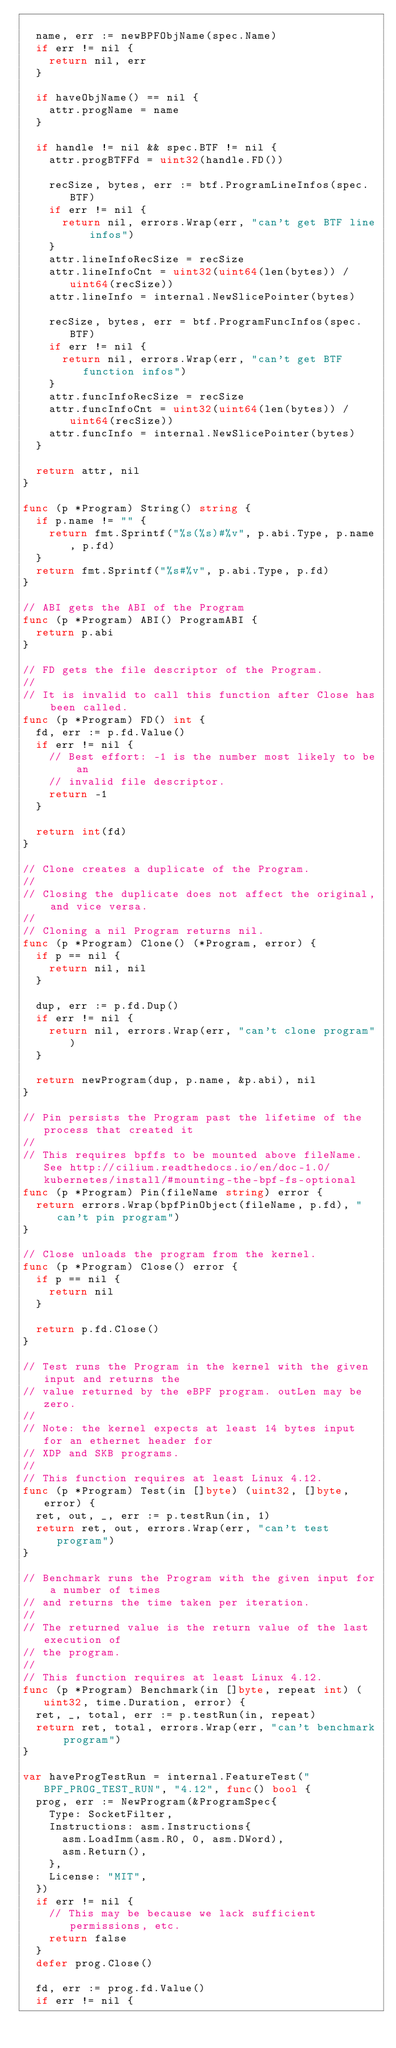<code> <loc_0><loc_0><loc_500><loc_500><_Go_>
	name, err := newBPFObjName(spec.Name)
	if err != nil {
		return nil, err
	}

	if haveObjName() == nil {
		attr.progName = name
	}

	if handle != nil && spec.BTF != nil {
		attr.progBTFFd = uint32(handle.FD())

		recSize, bytes, err := btf.ProgramLineInfos(spec.BTF)
		if err != nil {
			return nil, errors.Wrap(err, "can't get BTF line infos")
		}
		attr.lineInfoRecSize = recSize
		attr.lineInfoCnt = uint32(uint64(len(bytes)) / uint64(recSize))
		attr.lineInfo = internal.NewSlicePointer(bytes)

		recSize, bytes, err = btf.ProgramFuncInfos(spec.BTF)
		if err != nil {
			return nil, errors.Wrap(err, "can't get BTF function infos")
		}
		attr.funcInfoRecSize = recSize
		attr.funcInfoCnt = uint32(uint64(len(bytes)) / uint64(recSize))
		attr.funcInfo = internal.NewSlicePointer(bytes)
	}

	return attr, nil
}

func (p *Program) String() string {
	if p.name != "" {
		return fmt.Sprintf("%s(%s)#%v", p.abi.Type, p.name, p.fd)
	}
	return fmt.Sprintf("%s#%v", p.abi.Type, p.fd)
}

// ABI gets the ABI of the Program
func (p *Program) ABI() ProgramABI {
	return p.abi
}

// FD gets the file descriptor of the Program.
//
// It is invalid to call this function after Close has been called.
func (p *Program) FD() int {
	fd, err := p.fd.Value()
	if err != nil {
		// Best effort: -1 is the number most likely to be an
		// invalid file descriptor.
		return -1
	}

	return int(fd)
}

// Clone creates a duplicate of the Program.
//
// Closing the duplicate does not affect the original, and vice versa.
//
// Cloning a nil Program returns nil.
func (p *Program) Clone() (*Program, error) {
	if p == nil {
		return nil, nil
	}

	dup, err := p.fd.Dup()
	if err != nil {
		return nil, errors.Wrap(err, "can't clone program")
	}

	return newProgram(dup, p.name, &p.abi), nil
}

// Pin persists the Program past the lifetime of the process that created it
//
// This requires bpffs to be mounted above fileName. See http://cilium.readthedocs.io/en/doc-1.0/kubernetes/install/#mounting-the-bpf-fs-optional
func (p *Program) Pin(fileName string) error {
	return errors.Wrap(bpfPinObject(fileName, p.fd), "can't pin program")
}

// Close unloads the program from the kernel.
func (p *Program) Close() error {
	if p == nil {
		return nil
	}

	return p.fd.Close()
}

// Test runs the Program in the kernel with the given input and returns the
// value returned by the eBPF program. outLen may be zero.
//
// Note: the kernel expects at least 14 bytes input for an ethernet header for
// XDP and SKB programs.
//
// This function requires at least Linux 4.12.
func (p *Program) Test(in []byte) (uint32, []byte, error) {
	ret, out, _, err := p.testRun(in, 1)
	return ret, out, errors.Wrap(err, "can't test program")
}

// Benchmark runs the Program with the given input for a number of times
// and returns the time taken per iteration.
//
// The returned value is the return value of the last execution of
// the program.
//
// This function requires at least Linux 4.12.
func (p *Program) Benchmark(in []byte, repeat int) (uint32, time.Duration, error) {
	ret, _, total, err := p.testRun(in, repeat)
	return ret, total, errors.Wrap(err, "can't benchmark program")
}

var haveProgTestRun = internal.FeatureTest("BPF_PROG_TEST_RUN", "4.12", func() bool {
	prog, err := NewProgram(&ProgramSpec{
		Type: SocketFilter,
		Instructions: asm.Instructions{
			asm.LoadImm(asm.R0, 0, asm.DWord),
			asm.Return(),
		},
		License: "MIT",
	})
	if err != nil {
		// This may be because we lack sufficient permissions, etc.
		return false
	}
	defer prog.Close()

	fd, err := prog.fd.Value()
	if err != nil {</code> 